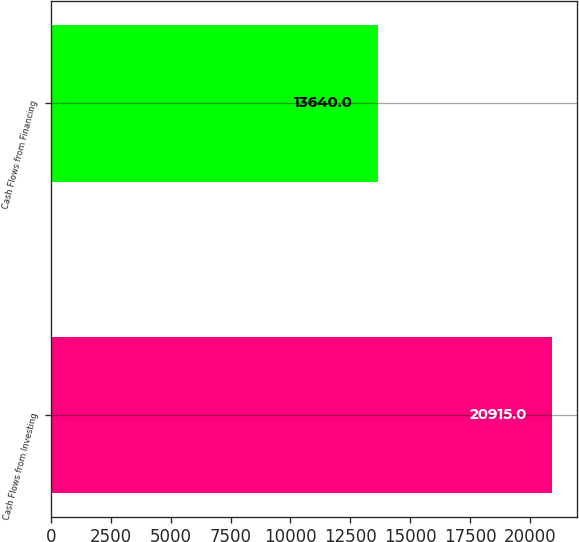Convert chart. <chart><loc_0><loc_0><loc_500><loc_500><bar_chart><fcel>Cash Flows from Investing<fcel>Cash Flows from Financing<nl><fcel>20915<fcel>13640<nl></chart> 